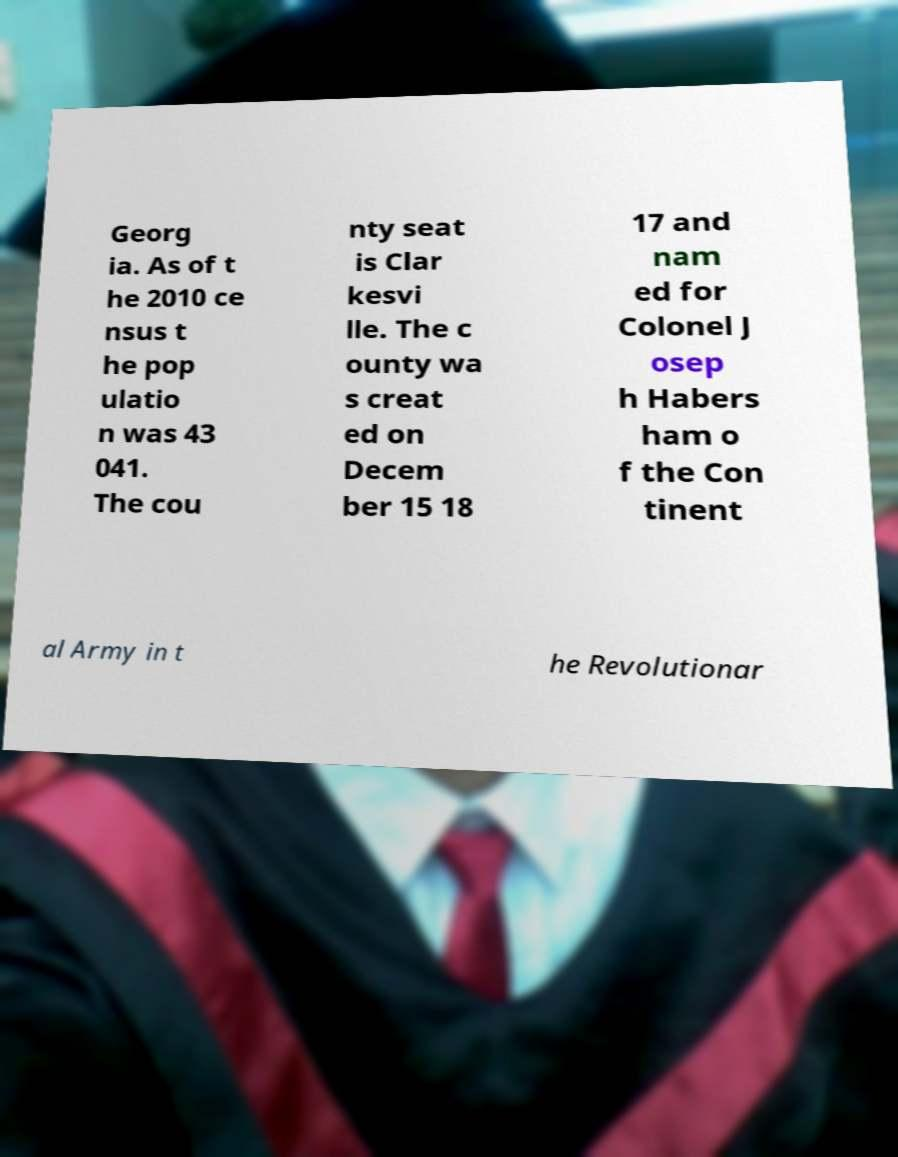Can you accurately transcribe the text from the provided image for me? Georg ia. As of t he 2010 ce nsus t he pop ulatio n was 43 041. The cou nty seat is Clar kesvi lle. The c ounty wa s creat ed on Decem ber 15 18 17 and nam ed for Colonel J osep h Habers ham o f the Con tinent al Army in t he Revolutionar 